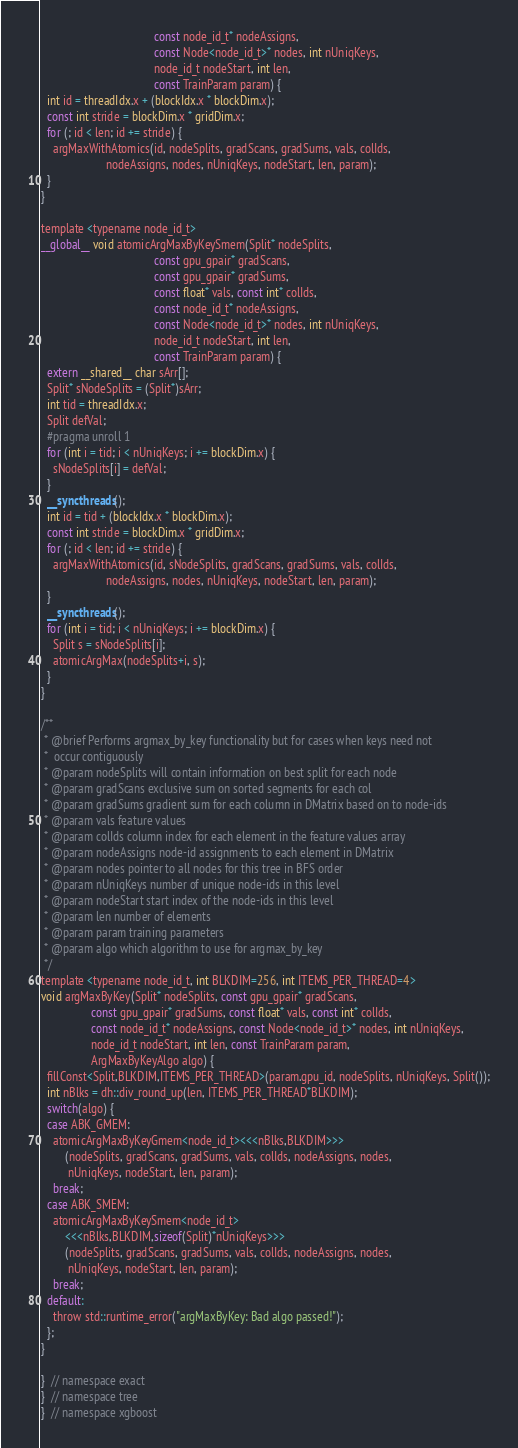Convert code to text. <code><loc_0><loc_0><loc_500><loc_500><_Cuda_>                                      const node_id_t* nodeAssigns,
                                      const Node<node_id_t>* nodes, int nUniqKeys,
                                      node_id_t nodeStart, int len,
                                      const TrainParam param) {
  int id = threadIdx.x + (blockIdx.x * blockDim.x);
  const int stride = blockDim.x * gridDim.x;
  for (; id < len; id += stride) {
    argMaxWithAtomics(id, nodeSplits, gradScans, gradSums, vals, colIds,
                      nodeAssigns, nodes, nUniqKeys, nodeStart, len, param);
  }
}

template <typename node_id_t>
__global__ void atomicArgMaxByKeySmem(Split* nodeSplits,
                                      const gpu_gpair* gradScans,
                                      const gpu_gpair* gradSums,
                                      const float* vals, const int* colIds,
                                      const node_id_t* nodeAssigns,
                                      const Node<node_id_t>* nodes, int nUniqKeys,
                                      node_id_t nodeStart, int len,
                                      const TrainParam param) {
  extern __shared__ char sArr[];
  Split* sNodeSplits = (Split*)sArr;
  int tid = threadIdx.x;
  Split defVal;
  #pragma unroll 1
  for (int i = tid; i < nUniqKeys; i += blockDim.x) {
    sNodeSplits[i] = defVal;
  }
  __syncthreads();
  int id = tid + (blockIdx.x * blockDim.x);
  const int stride = blockDim.x * gridDim.x;
  for (; id < len; id += stride) {
    argMaxWithAtomics(id, sNodeSplits, gradScans, gradSums, vals, colIds,
                      nodeAssigns, nodes, nUniqKeys, nodeStart, len, param);
  }
  __syncthreads();
  for (int i = tid; i < nUniqKeys; i += blockDim.x) {
    Split s = sNodeSplits[i];
    atomicArgMax(nodeSplits+i, s);
  }
}

/**
 * @brief Performs argmax_by_key functionality but for cases when keys need not
 *  occur contiguously
 * @param nodeSplits will contain information on best split for each node
 * @param gradScans exclusive sum on sorted segments for each col
 * @param gradSums gradient sum for each column in DMatrix based on to node-ids
 * @param vals feature values
 * @param colIds column index for each element in the feature values array
 * @param nodeAssigns node-id assignments to each element in DMatrix
 * @param nodes pointer to all nodes for this tree in BFS order
 * @param nUniqKeys number of unique node-ids in this level
 * @param nodeStart start index of the node-ids in this level
 * @param len number of elements
 * @param param training parameters
 * @param algo which algorithm to use for argmax_by_key
 */
template <typename node_id_t, int BLKDIM=256, int ITEMS_PER_THREAD=4>
void argMaxByKey(Split* nodeSplits, const gpu_gpair* gradScans,
                 const gpu_gpair* gradSums, const float* vals, const int* colIds,
                 const node_id_t* nodeAssigns, const Node<node_id_t>* nodes, int nUniqKeys,
                 node_id_t nodeStart, int len, const TrainParam param,
                 ArgMaxByKeyAlgo algo) {
  fillConst<Split,BLKDIM,ITEMS_PER_THREAD>(param.gpu_id, nodeSplits, nUniqKeys, Split());
  int nBlks = dh::div_round_up(len, ITEMS_PER_THREAD*BLKDIM);
  switch(algo) {
  case ABK_GMEM:
    atomicArgMaxByKeyGmem<node_id_t><<<nBlks,BLKDIM>>>
        (nodeSplits, gradScans, gradSums, vals, colIds, nodeAssigns, nodes,
         nUniqKeys, nodeStart, len, param);
    break;
  case ABK_SMEM:
    atomicArgMaxByKeySmem<node_id_t>
        <<<nBlks,BLKDIM,sizeof(Split)*nUniqKeys>>>
        (nodeSplits, gradScans, gradSums, vals, colIds, nodeAssigns, nodes,
         nUniqKeys, nodeStart, len, param);
    break;
  default:
    throw std::runtime_error("argMaxByKey: Bad algo passed!");
  };
}

}  // namespace exact
}  // namespace tree
}  // namespace xgboost
</code> 